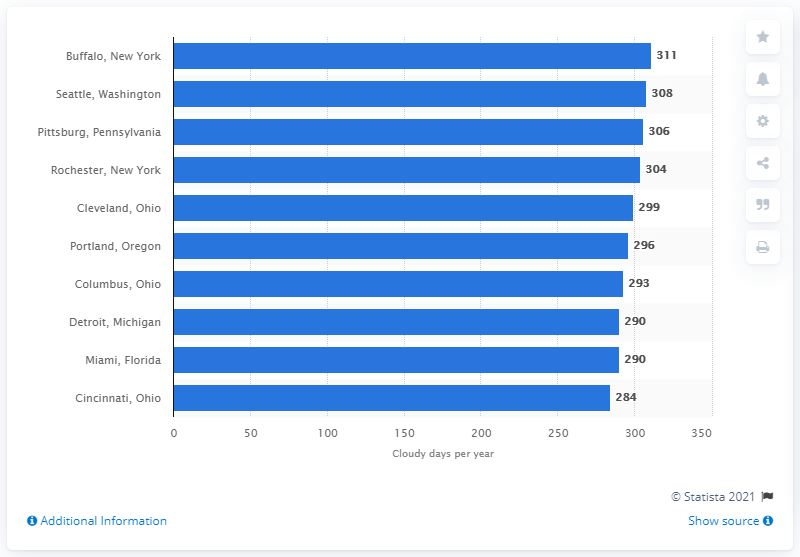Can you tell me more about how weather patterns might affect the number of cloudy days in these cities? Certainly, weather patterns in different regions can significantly influence the number of cloudy days. For example, cities located near large bodies of water like the Great Lakes, or in areas with frequent weather systems from the coast, may experience more clouds. Conversely, cities situated in drier climates or with prevailing weather patterns that discourage cloud formation might enjoy more clear days. 